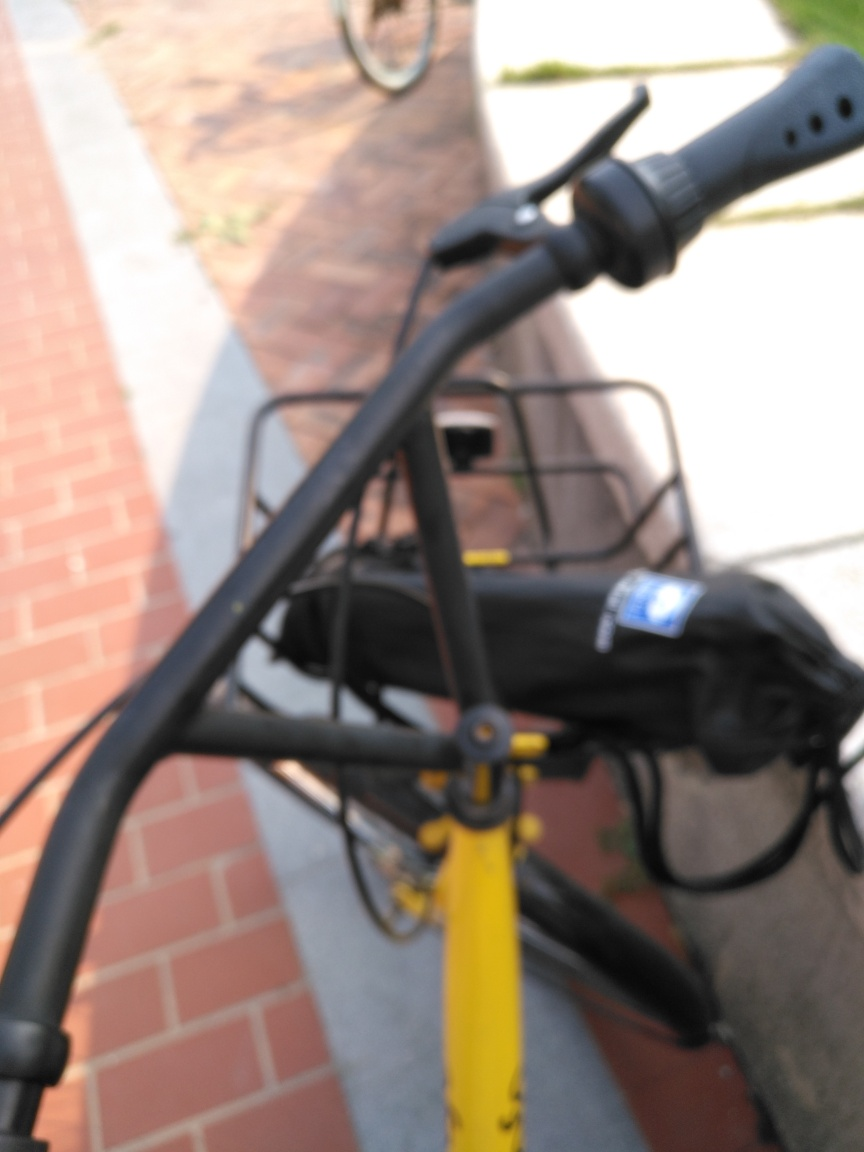What is the setting of this image? The setting of the image appears to be an outdoor urban environment, likely a sidewalk alongside a street judging from the brickwork on the ground and the portion of the road visible at the edge of the frame. What mood does this image evoke? The blurry aesthetics may evoke a sense of motion or haste, potentially capturing the essence of urban life where everything moves quickly and sometimes becomes a blur. 